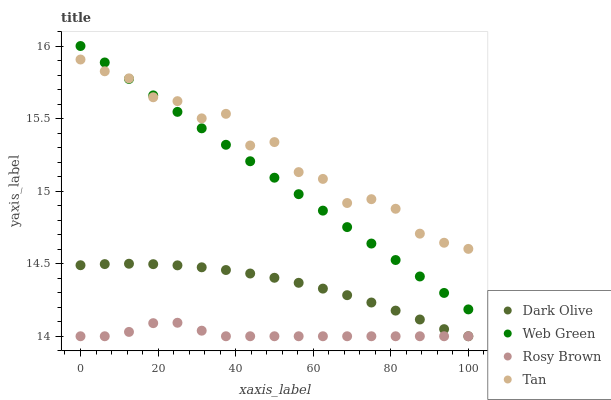Does Rosy Brown have the minimum area under the curve?
Answer yes or no. Yes. Does Tan have the maximum area under the curve?
Answer yes or no. Yes. Does Dark Olive have the minimum area under the curve?
Answer yes or no. No. Does Dark Olive have the maximum area under the curve?
Answer yes or no. No. Is Web Green the smoothest?
Answer yes or no. Yes. Is Tan the roughest?
Answer yes or no. Yes. Is Dark Olive the smoothest?
Answer yes or no. No. Is Dark Olive the roughest?
Answer yes or no. No. Does Rosy Brown have the lowest value?
Answer yes or no. Yes. Does Tan have the lowest value?
Answer yes or no. No. Does Web Green have the highest value?
Answer yes or no. Yes. Does Dark Olive have the highest value?
Answer yes or no. No. Is Dark Olive less than Web Green?
Answer yes or no. Yes. Is Web Green greater than Rosy Brown?
Answer yes or no. Yes. Does Tan intersect Web Green?
Answer yes or no. Yes. Is Tan less than Web Green?
Answer yes or no. No. Is Tan greater than Web Green?
Answer yes or no. No. Does Dark Olive intersect Web Green?
Answer yes or no. No. 